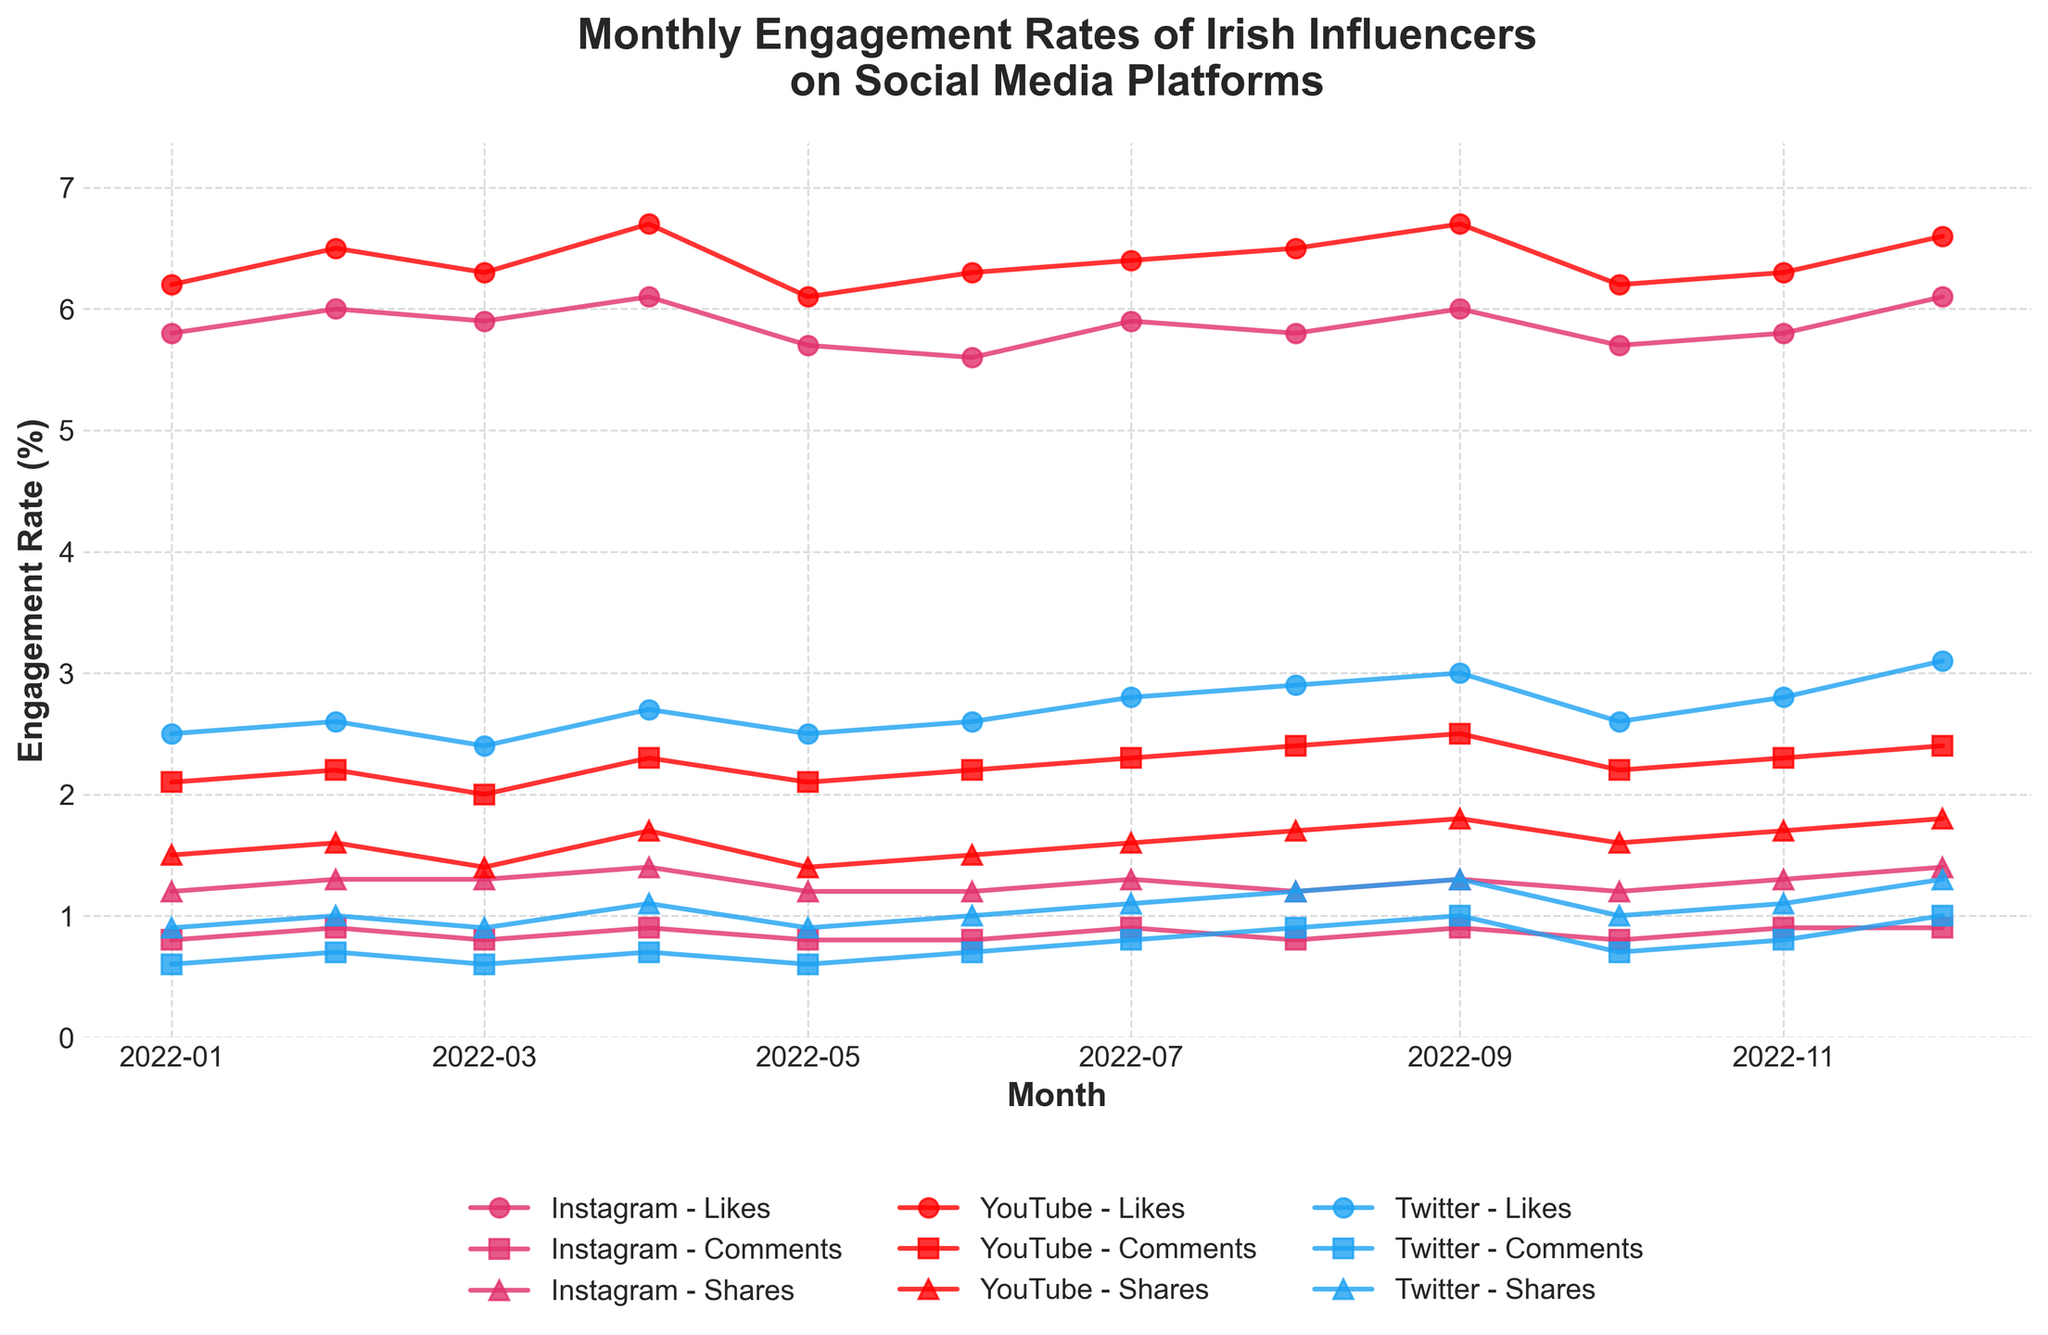What is the title of the figure? The title of the figure is displayed at the top of the plot in a bold and slightly larger font. It indicates the general purpose or subject of the data being visualized. The title helps in quickly understanding what the plot is about without diving into the details.
Answer: Monthly Engagement Rates of Irish Influencers on Social Media Platforms How many social media platforms are represented in the figure? The platforms are identified by different colors and legend labels. By counting the unique platforms listed in the legend, we can determine the total number of platforms represented.
Answer: 3 During which month did Instagram have the highest engagement rate for likes? Look at the Instagram engagement rate for likes across each month. The month with the highest peak on the time series line for likes indicates the month with the highest engagement.
Answer: December 2022 What’s the trend in YouTube comments engagement rate over the year? By following the YouTube comments line throughout the year, observe if it’s increasing, decreasing, or remaining stable. Note the slope changes to understand the trend.
Answer: Generally increasing In which month did Twitter have the lowest engagement rate for shares? Look for the lowest point in the Twitter shares time series line. The month corresponding to this point indicates when Twitter shares had the lowest engagement rate.
Answer: January 2022 How does the engagement rate for comments on Instagram in January 2022 compare to that in December 2022? Compare the data points for comments on Instagram in January and December 2022 by checking their respective heights on the plot. Observing if one is higher or lower will give the comparison.
Answer: Increased What is the average engagement rate of likes on Instagram over the year? Sum all the engagement rate values for likes on Instagram across each month, then divide this total by the number of months (12).
Answer: (5.8 + 6.0 + 5.9 + 6.1 + 5.7 + 5.6 + 5.9 + 5.8 + 6.0 + 5.7 + 5.8 + 6.1) / 12 = 5.87 Which platform had the highest engagement rate for shares in September 2022? Observe the engagement rates for shares across all platforms in September 2022. The platform with the highest peak on the plot for that month represents the answer.
Answer: YouTube How do the engagement rates of likes on Instagram and Twitter in August 2022 compare? Examine the time series lines for Instagram and Twitter likes in August 2022. Compare their heights to determine which platform had a higher engagement rate.
Answer: Instagram had higher likes What is the range of engagement rates for YouTube shares over the year? Identify the maximum and minimum engagement rates for YouTube shares by finding the highest and lowest points on the YouTube shares time series line. The range is calculated as the difference between these two values.
Answer: 1.8 - 1.4 = 0.4 